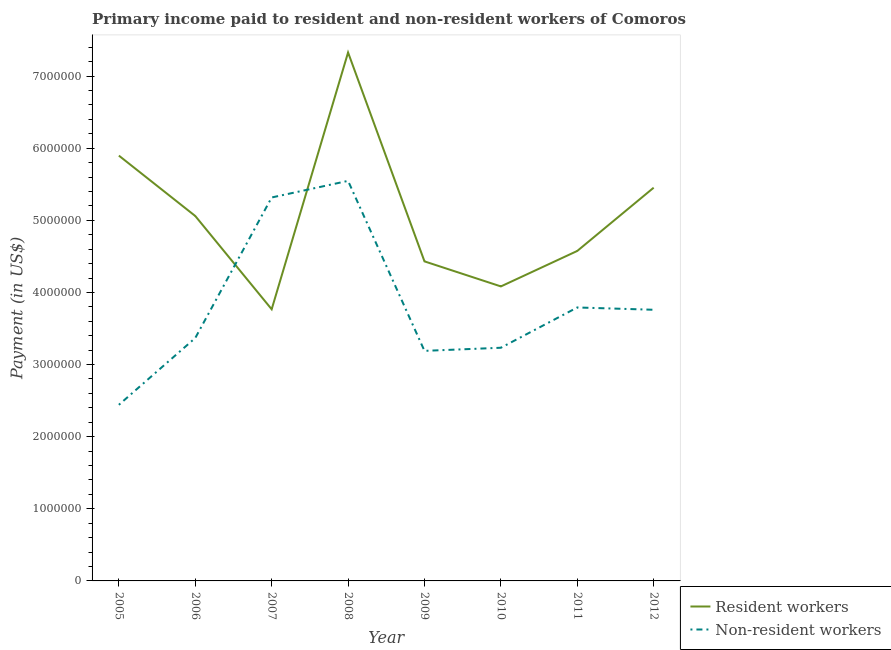How many different coloured lines are there?
Your response must be concise. 2. What is the payment made to non-resident workers in 2006?
Your answer should be compact. 3.37e+06. Across all years, what is the maximum payment made to resident workers?
Offer a terse response. 7.33e+06. Across all years, what is the minimum payment made to resident workers?
Your response must be concise. 3.77e+06. In which year was the payment made to non-resident workers maximum?
Provide a succinct answer. 2008. What is the total payment made to non-resident workers in the graph?
Offer a very short reply. 3.06e+07. What is the difference between the payment made to resident workers in 2007 and that in 2009?
Offer a very short reply. -6.64e+05. What is the difference between the payment made to resident workers in 2012 and the payment made to non-resident workers in 2011?
Your answer should be compact. 1.66e+06. What is the average payment made to non-resident workers per year?
Provide a succinct answer. 3.83e+06. In the year 2012, what is the difference between the payment made to resident workers and payment made to non-resident workers?
Your answer should be compact. 1.69e+06. In how many years, is the payment made to non-resident workers greater than 4400000 US$?
Offer a very short reply. 2. What is the ratio of the payment made to resident workers in 2008 to that in 2011?
Your answer should be very brief. 1.6. Is the payment made to non-resident workers in 2005 less than that in 2006?
Your answer should be very brief. Yes. Is the difference between the payment made to non-resident workers in 2005 and 2007 greater than the difference between the payment made to resident workers in 2005 and 2007?
Offer a terse response. No. What is the difference between the highest and the second highest payment made to non-resident workers?
Your response must be concise. 2.30e+05. What is the difference between the highest and the lowest payment made to non-resident workers?
Offer a terse response. 3.11e+06. Is the sum of the payment made to non-resident workers in 2005 and 2007 greater than the maximum payment made to resident workers across all years?
Give a very brief answer. Yes. How many lines are there?
Provide a succinct answer. 2. What is the difference between two consecutive major ticks on the Y-axis?
Keep it short and to the point. 1.00e+06. Does the graph contain any zero values?
Offer a very short reply. No. How are the legend labels stacked?
Provide a short and direct response. Vertical. What is the title of the graph?
Provide a succinct answer. Primary income paid to resident and non-resident workers of Comoros. What is the label or title of the X-axis?
Your response must be concise. Year. What is the label or title of the Y-axis?
Your response must be concise. Payment (in US$). What is the Payment (in US$) in Resident workers in 2005?
Provide a succinct answer. 5.90e+06. What is the Payment (in US$) in Non-resident workers in 2005?
Your answer should be compact. 2.44e+06. What is the Payment (in US$) in Resident workers in 2006?
Ensure brevity in your answer.  5.06e+06. What is the Payment (in US$) of Non-resident workers in 2006?
Your answer should be compact. 3.37e+06. What is the Payment (in US$) in Resident workers in 2007?
Keep it short and to the point. 3.77e+06. What is the Payment (in US$) in Non-resident workers in 2007?
Offer a terse response. 5.32e+06. What is the Payment (in US$) of Resident workers in 2008?
Keep it short and to the point. 7.33e+06. What is the Payment (in US$) of Non-resident workers in 2008?
Your answer should be compact. 5.55e+06. What is the Payment (in US$) of Resident workers in 2009?
Your response must be concise. 4.43e+06. What is the Payment (in US$) in Non-resident workers in 2009?
Provide a short and direct response. 3.19e+06. What is the Payment (in US$) of Resident workers in 2010?
Provide a succinct answer. 4.08e+06. What is the Payment (in US$) in Non-resident workers in 2010?
Offer a very short reply. 3.23e+06. What is the Payment (in US$) of Resident workers in 2011?
Offer a terse response. 4.58e+06. What is the Payment (in US$) of Non-resident workers in 2011?
Keep it short and to the point. 3.79e+06. What is the Payment (in US$) in Resident workers in 2012?
Offer a very short reply. 5.45e+06. What is the Payment (in US$) in Non-resident workers in 2012?
Your answer should be very brief. 3.76e+06. Across all years, what is the maximum Payment (in US$) of Resident workers?
Your answer should be very brief. 7.33e+06. Across all years, what is the maximum Payment (in US$) of Non-resident workers?
Offer a terse response. 5.55e+06. Across all years, what is the minimum Payment (in US$) of Resident workers?
Keep it short and to the point. 3.77e+06. Across all years, what is the minimum Payment (in US$) in Non-resident workers?
Provide a succinct answer. 2.44e+06. What is the total Payment (in US$) in Resident workers in the graph?
Your answer should be compact. 4.06e+07. What is the total Payment (in US$) of Non-resident workers in the graph?
Your answer should be compact. 3.06e+07. What is the difference between the Payment (in US$) of Resident workers in 2005 and that in 2006?
Your answer should be very brief. 8.37e+05. What is the difference between the Payment (in US$) in Non-resident workers in 2005 and that in 2006?
Ensure brevity in your answer.  -9.27e+05. What is the difference between the Payment (in US$) of Resident workers in 2005 and that in 2007?
Your response must be concise. 2.13e+06. What is the difference between the Payment (in US$) of Non-resident workers in 2005 and that in 2007?
Make the answer very short. -2.87e+06. What is the difference between the Payment (in US$) in Resident workers in 2005 and that in 2008?
Provide a succinct answer. -1.43e+06. What is the difference between the Payment (in US$) of Non-resident workers in 2005 and that in 2008?
Keep it short and to the point. -3.11e+06. What is the difference between the Payment (in US$) of Resident workers in 2005 and that in 2009?
Ensure brevity in your answer.  1.47e+06. What is the difference between the Payment (in US$) in Non-resident workers in 2005 and that in 2009?
Your response must be concise. -7.48e+05. What is the difference between the Payment (in US$) in Resident workers in 2005 and that in 2010?
Give a very brief answer. 1.81e+06. What is the difference between the Payment (in US$) in Non-resident workers in 2005 and that in 2010?
Ensure brevity in your answer.  -7.91e+05. What is the difference between the Payment (in US$) of Resident workers in 2005 and that in 2011?
Keep it short and to the point. 1.32e+06. What is the difference between the Payment (in US$) in Non-resident workers in 2005 and that in 2011?
Make the answer very short. -1.35e+06. What is the difference between the Payment (in US$) of Resident workers in 2005 and that in 2012?
Ensure brevity in your answer.  4.45e+05. What is the difference between the Payment (in US$) in Non-resident workers in 2005 and that in 2012?
Your response must be concise. -1.32e+06. What is the difference between the Payment (in US$) of Resident workers in 2006 and that in 2007?
Make the answer very short. 1.29e+06. What is the difference between the Payment (in US$) in Non-resident workers in 2006 and that in 2007?
Offer a very short reply. -1.95e+06. What is the difference between the Payment (in US$) in Resident workers in 2006 and that in 2008?
Ensure brevity in your answer.  -2.27e+06. What is the difference between the Payment (in US$) of Non-resident workers in 2006 and that in 2008?
Provide a succinct answer. -2.18e+06. What is the difference between the Payment (in US$) in Resident workers in 2006 and that in 2009?
Provide a succinct answer. 6.29e+05. What is the difference between the Payment (in US$) in Non-resident workers in 2006 and that in 2009?
Your response must be concise. 1.78e+05. What is the difference between the Payment (in US$) of Resident workers in 2006 and that in 2010?
Provide a short and direct response. 9.76e+05. What is the difference between the Payment (in US$) in Non-resident workers in 2006 and that in 2010?
Make the answer very short. 1.35e+05. What is the difference between the Payment (in US$) of Resident workers in 2006 and that in 2011?
Offer a terse response. 4.84e+05. What is the difference between the Payment (in US$) of Non-resident workers in 2006 and that in 2011?
Offer a terse response. -4.23e+05. What is the difference between the Payment (in US$) in Resident workers in 2006 and that in 2012?
Keep it short and to the point. -3.93e+05. What is the difference between the Payment (in US$) in Non-resident workers in 2006 and that in 2012?
Your answer should be very brief. -3.91e+05. What is the difference between the Payment (in US$) of Resident workers in 2007 and that in 2008?
Your answer should be compact. -3.56e+06. What is the difference between the Payment (in US$) of Non-resident workers in 2007 and that in 2008?
Your answer should be compact. -2.30e+05. What is the difference between the Payment (in US$) in Resident workers in 2007 and that in 2009?
Your response must be concise. -6.64e+05. What is the difference between the Payment (in US$) of Non-resident workers in 2007 and that in 2009?
Offer a very short reply. 2.13e+06. What is the difference between the Payment (in US$) in Resident workers in 2007 and that in 2010?
Offer a terse response. -3.17e+05. What is the difference between the Payment (in US$) in Non-resident workers in 2007 and that in 2010?
Your answer should be compact. 2.08e+06. What is the difference between the Payment (in US$) of Resident workers in 2007 and that in 2011?
Your answer should be compact. -8.09e+05. What is the difference between the Payment (in US$) in Non-resident workers in 2007 and that in 2011?
Provide a short and direct response. 1.52e+06. What is the difference between the Payment (in US$) in Resident workers in 2007 and that in 2012?
Keep it short and to the point. -1.69e+06. What is the difference between the Payment (in US$) in Non-resident workers in 2007 and that in 2012?
Keep it short and to the point. 1.56e+06. What is the difference between the Payment (in US$) in Resident workers in 2008 and that in 2009?
Your response must be concise. 2.90e+06. What is the difference between the Payment (in US$) in Non-resident workers in 2008 and that in 2009?
Your answer should be compact. 2.36e+06. What is the difference between the Payment (in US$) of Resident workers in 2008 and that in 2010?
Ensure brevity in your answer.  3.24e+06. What is the difference between the Payment (in US$) of Non-resident workers in 2008 and that in 2010?
Offer a terse response. 2.31e+06. What is the difference between the Payment (in US$) in Resident workers in 2008 and that in 2011?
Give a very brief answer. 2.75e+06. What is the difference between the Payment (in US$) of Non-resident workers in 2008 and that in 2011?
Your response must be concise. 1.76e+06. What is the difference between the Payment (in US$) of Resident workers in 2008 and that in 2012?
Give a very brief answer. 1.87e+06. What is the difference between the Payment (in US$) of Non-resident workers in 2008 and that in 2012?
Give a very brief answer. 1.79e+06. What is the difference between the Payment (in US$) of Resident workers in 2009 and that in 2010?
Offer a terse response. 3.47e+05. What is the difference between the Payment (in US$) in Non-resident workers in 2009 and that in 2010?
Provide a succinct answer. -4.30e+04. What is the difference between the Payment (in US$) of Resident workers in 2009 and that in 2011?
Make the answer very short. -1.45e+05. What is the difference between the Payment (in US$) of Non-resident workers in 2009 and that in 2011?
Provide a succinct answer. -6.02e+05. What is the difference between the Payment (in US$) in Resident workers in 2009 and that in 2012?
Ensure brevity in your answer.  -1.02e+06. What is the difference between the Payment (in US$) in Non-resident workers in 2009 and that in 2012?
Give a very brief answer. -5.70e+05. What is the difference between the Payment (in US$) of Resident workers in 2010 and that in 2011?
Keep it short and to the point. -4.92e+05. What is the difference between the Payment (in US$) of Non-resident workers in 2010 and that in 2011?
Offer a terse response. -5.59e+05. What is the difference between the Payment (in US$) in Resident workers in 2010 and that in 2012?
Keep it short and to the point. -1.37e+06. What is the difference between the Payment (in US$) in Non-resident workers in 2010 and that in 2012?
Provide a succinct answer. -5.27e+05. What is the difference between the Payment (in US$) of Resident workers in 2011 and that in 2012?
Keep it short and to the point. -8.77e+05. What is the difference between the Payment (in US$) of Non-resident workers in 2011 and that in 2012?
Your response must be concise. 3.19e+04. What is the difference between the Payment (in US$) of Resident workers in 2005 and the Payment (in US$) of Non-resident workers in 2006?
Ensure brevity in your answer.  2.53e+06. What is the difference between the Payment (in US$) in Resident workers in 2005 and the Payment (in US$) in Non-resident workers in 2007?
Ensure brevity in your answer.  5.81e+05. What is the difference between the Payment (in US$) of Resident workers in 2005 and the Payment (in US$) of Non-resident workers in 2008?
Your answer should be very brief. 3.50e+05. What is the difference between the Payment (in US$) in Resident workers in 2005 and the Payment (in US$) in Non-resident workers in 2009?
Make the answer very short. 2.71e+06. What is the difference between the Payment (in US$) in Resident workers in 2005 and the Payment (in US$) in Non-resident workers in 2010?
Give a very brief answer. 2.66e+06. What is the difference between the Payment (in US$) in Resident workers in 2005 and the Payment (in US$) in Non-resident workers in 2011?
Make the answer very short. 2.11e+06. What is the difference between the Payment (in US$) in Resident workers in 2005 and the Payment (in US$) in Non-resident workers in 2012?
Provide a succinct answer. 2.14e+06. What is the difference between the Payment (in US$) in Resident workers in 2006 and the Payment (in US$) in Non-resident workers in 2007?
Offer a terse response. -2.57e+05. What is the difference between the Payment (in US$) in Resident workers in 2006 and the Payment (in US$) in Non-resident workers in 2008?
Offer a very short reply. -4.87e+05. What is the difference between the Payment (in US$) in Resident workers in 2006 and the Payment (in US$) in Non-resident workers in 2009?
Provide a short and direct response. 1.87e+06. What is the difference between the Payment (in US$) of Resident workers in 2006 and the Payment (in US$) of Non-resident workers in 2010?
Provide a short and direct response. 1.83e+06. What is the difference between the Payment (in US$) of Resident workers in 2006 and the Payment (in US$) of Non-resident workers in 2011?
Your response must be concise. 1.27e+06. What is the difference between the Payment (in US$) of Resident workers in 2006 and the Payment (in US$) of Non-resident workers in 2012?
Your answer should be compact. 1.30e+06. What is the difference between the Payment (in US$) in Resident workers in 2007 and the Payment (in US$) in Non-resident workers in 2008?
Offer a terse response. -1.78e+06. What is the difference between the Payment (in US$) in Resident workers in 2007 and the Payment (in US$) in Non-resident workers in 2009?
Provide a succinct answer. 5.77e+05. What is the difference between the Payment (in US$) of Resident workers in 2007 and the Payment (in US$) of Non-resident workers in 2010?
Make the answer very short. 5.34e+05. What is the difference between the Payment (in US$) of Resident workers in 2007 and the Payment (in US$) of Non-resident workers in 2011?
Your response must be concise. -2.51e+04. What is the difference between the Payment (in US$) of Resident workers in 2007 and the Payment (in US$) of Non-resident workers in 2012?
Make the answer very short. 6854.8. What is the difference between the Payment (in US$) of Resident workers in 2008 and the Payment (in US$) of Non-resident workers in 2009?
Offer a very short reply. 4.14e+06. What is the difference between the Payment (in US$) of Resident workers in 2008 and the Payment (in US$) of Non-resident workers in 2010?
Provide a short and direct response. 4.09e+06. What is the difference between the Payment (in US$) of Resident workers in 2008 and the Payment (in US$) of Non-resident workers in 2011?
Provide a short and direct response. 3.54e+06. What is the difference between the Payment (in US$) of Resident workers in 2008 and the Payment (in US$) of Non-resident workers in 2012?
Offer a terse response. 3.57e+06. What is the difference between the Payment (in US$) in Resident workers in 2009 and the Payment (in US$) in Non-resident workers in 2010?
Your response must be concise. 1.20e+06. What is the difference between the Payment (in US$) in Resident workers in 2009 and the Payment (in US$) in Non-resident workers in 2011?
Offer a very short reply. 6.39e+05. What is the difference between the Payment (in US$) in Resident workers in 2009 and the Payment (in US$) in Non-resident workers in 2012?
Ensure brevity in your answer.  6.71e+05. What is the difference between the Payment (in US$) in Resident workers in 2010 and the Payment (in US$) in Non-resident workers in 2011?
Give a very brief answer. 2.92e+05. What is the difference between the Payment (in US$) of Resident workers in 2010 and the Payment (in US$) of Non-resident workers in 2012?
Your answer should be very brief. 3.24e+05. What is the difference between the Payment (in US$) of Resident workers in 2011 and the Payment (in US$) of Non-resident workers in 2012?
Keep it short and to the point. 8.16e+05. What is the average Payment (in US$) in Resident workers per year?
Keep it short and to the point. 5.07e+06. What is the average Payment (in US$) of Non-resident workers per year?
Your answer should be compact. 3.83e+06. In the year 2005, what is the difference between the Payment (in US$) in Resident workers and Payment (in US$) in Non-resident workers?
Your answer should be compact. 3.46e+06. In the year 2006, what is the difference between the Payment (in US$) in Resident workers and Payment (in US$) in Non-resident workers?
Your answer should be very brief. 1.69e+06. In the year 2007, what is the difference between the Payment (in US$) of Resident workers and Payment (in US$) of Non-resident workers?
Offer a very short reply. -1.55e+06. In the year 2008, what is the difference between the Payment (in US$) in Resident workers and Payment (in US$) in Non-resident workers?
Offer a terse response. 1.78e+06. In the year 2009, what is the difference between the Payment (in US$) of Resident workers and Payment (in US$) of Non-resident workers?
Offer a very short reply. 1.24e+06. In the year 2010, what is the difference between the Payment (in US$) of Resident workers and Payment (in US$) of Non-resident workers?
Give a very brief answer. 8.51e+05. In the year 2011, what is the difference between the Payment (in US$) in Resident workers and Payment (in US$) in Non-resident workers?
Ensure brevity in your answer.  7.84e+05. In the year 2012, what is the difference between the Payment (in US$) of Resident workers and Payment (in US$) of Non-resident workers?
Make the answer very short. 1.69e+06. What is the ratio of the Payment (in US$) of Resident workers in 2005 to that in 2006?
Your answer should be very brief. 1.17. What is the ratio of the Payment (in US$) in Non-resident workers in 2005 to that in 2006?
Keep it short and to the point. 0.72. What is the ratio of the Payment (in US$) of Resident workers in 2005 to that in 2007?
Make the answer very short. 1.57. What is the ratio of the Payment (in US$) in Non-resident workers in 2005 to that in 2007?
Offer a terse response. 0.46. What is the ratio of the Payment (in US$) of Resident workers in 2005 to that in 2008?
Offer a very short reply. 0.8. What is the ratio of the Payment (in US$) in Non-resident workers in 2005 to that in 2008?
Make the answer very short. 0.44. What is the ratio of the Payment (in US$) of Resident workers in 2005 to that in 2009?
Offer a terse response. 1.33. What is the ratio of the Payment (in US$) in Non-resident workers in 2005 to that in 2009?
Your answer should be compact. 0.77. What is the ratio of the Payment (in US$) in Resident workers in 2005 to that in 2010?
Ensure brevity in your answer.  1.44. What is the ratio of the Payment (in US$) of Non-resident workers in 2005 to that in 2010?
Offer a very short reply. 0.76. What is the ratio of the Payment (in US$) of Resident workers in 2005 to that in 2011?
Give a very brief answer. 1.29. What is the ratio of the Payment (in US$) of Non-resident workers in 2005 to that in 2011?
Offer a terse response. 0.64. What is the ratio of the Payment (in US$) in Resident workers in 2005 to that in 2012?
Keep it short and to the point. 1.08. What is the ratio of the Payment (in US$) in Non-resident workers in 2005 to that in 2012?
Your response must be concise. 0.65. What is the ratio of the Payment (in US$) in Resident workers in 2006 to that in 2007?
Keep it short and to the point. 1.34. What is the ratio of the Payment (in US$) in Non-resident workers in 2006 to that in 2007?
Keep it short and to the point. 0.63. What is the ratio of the Payment (in US$) in Resident workers in 2006 to that in 2008?
Your answer should be very brief. 0.69. What is the ratio of the Payment (in US$) in Non-resident workers in 2006 to that in 2008?
Your answer should be very brief. 0.61. What is the ratio of the Payment (in US$) in Resident workers in 2006 to that in 2009?
Make the answer very short. 1.14. What is the ratio of the Payment (in US$) of Non-resident workers in 2006 to that in 2009?
Your answer should be very brief. 1.06. What is the ratio of the Payment (in US$) in Resident workers in 2006 to that in 2010?
Ensure brevity in your answer.  1.24. What is the ratio of the Payment (in US$) in Non-resident workers in 2006 to that in 2010?
Your answer should be compact. 1.04. What is the ratio of the Payment (in US$) of Resident workers in 2006 to that in 2011?
Offer a terse response. 1.11. What is the ratio of the Payment (in US$) in Non-resident workers in 2006 to that in 2011?
Your answer should be compact. 0.89. What is the ratio of the Payment (in US$) of Resident workers in 2006 to that in 2012?
Your response must be concise. 0.93. What is the ratio of the Payment (in US$) of Non-resident workers in 2006 to that in 2012?
Ensure brevity in your answer.  0.9. What is the ratio of the Payment (in US$) of Resident workers in 2007 to that in 2008?
Keep it short and to the point. 0.51. What is the ratio of the Payment (in US$) of Non-resident workers in 2007 to that in 2008?
Your answer should be very brief. 0.96. What is the ratio of the Payment (in US$) in Resident workers in 2007 to that in 2009?
Your response must be concise. 0.85. What is the ratio of the Payment (in US$) in Non-resident workers in 2007 to that in 2009?
Give a very brief answer. 1.67. What is the ratio of the Payment (in US$) in Resident workers in 2007 to that in 2010?
Offer a terse response. 0.92. What is the ratio of the Payment (in US$) in Non-resident workers in 2007 to that in 2010?
Your response must be concise. 1.64. What is the ratio of the Payment (in US$) in Resident workers in 2007 to that in 2011?
Ensure brevity in your answer.  0.82. What is the ratio of the Payment (in US$) in Non-resident workers in 2007 to that in 2011?
Your answer should be compact. 1.4. What is the ratio of the Payment (in US$) of Resident workers in 2007 to that in 2012?
Your answer should be very brief. 0.69. What is the ratio of the Payment (in US$) of Non-resident workers in 2007 to that in 2012?
Your answer should be compact. 1.41. What is the ratio of the Payment (in US$) in Resident workers in 2008 to that in 2009?
Offer a very short reply. 1.65. What is the ratio of the Payment (in US$) in Non-resident workers in 2008 to that in 2009?
Make the answer very short. 1.74. What is the ratio of the Payment (in US$) of Resident workers in 2008 to that in 2010?
Your answer should be very brief. 1.79. What is the ratio of the Payment (in US$) in Non-resident workers in 2008 to that in 2010?
Keep it short and to the point. 1.72. What is the ratio of the Payment (in US$) in Resident workers in 2008 to that in 2011?
Offer a terse response. 1.6. What is the ratio of the Payment (in US$) of Non-resident workers in 2008 to that in 2011?
Your answer should be very brief. 1.46. What is the ratio of the Payment (in US$) in Resident workers in 2008 to that in 2012?
Keep it short and to the point. 1.34. What is the ratio of the Payment (in US$) in Non-resident workers in 2008 to that in 2012?
Your answer should be compact. 1.48. What is the ratio of the Payment (in US$) in Resident workers in 2009 to that in 2010?
Your answer should be compact. 1.08. What is the ratio of the Payment (in US$) of Non-resident workers in 2009 to that in 2010?
Ensure brevity in your answer.  0.99. What is the ratio of the Payment (in US$) of Resident workers in 2009 to that in 2011?
Give a very brief answer. 0.97. What is the ratio of the Payment (in US$) in Non-resident workers in 2009 to that in 2011?
Provide a short and direct response. 0.84. What is the ratio of the Payment (in US$) of Resident workers in 2009 to that in 2012?
Your answer should be very brief. 0.81. What is the ratio of the Payment (in US$) in Non-resident workers in 2009 to that in 2012?
Your answer should be very brief. 0.85. What is the ratio of the Payment (in US$) of Resident workers in 2010 to that in 2011?
Your answer should be compact. 0.89. What is the ratio of the Payment (in US$) of Non-resident workers in 2010 to that in 2011?
Your answer should be compact. 0.85. What is the ratio of the Payment (in US$) of Resident workers in 2010 to that in 2012?
Ensure brevity in your answer.  0.75. What is the ratio of the Payment (in US$) in Non-resident workers in 2010 to that in 2012?
Offer a very short reply. 0.86. What is the ratio of the Payment (in US$) in Resident workers in 2011 to that in 2012?
Ensure brevity in your answer.  0.84. What is the ratio of the Payment (in US$) in Non-resident workers in 2011 to that in 2012?
Keep it short and to the point. 1.01. What is the difference between the highest and the second highest Payment (in US$) of Resident workers?
Make the answer very short. 1.43e+06. What is the difference between the highest and the second highest Payment (in US$) of Non-resident workers?
Give a very brief answer. 2.30e+05. What is the difference between the highest and the lowest Payment (in US$) of Resident workers?
Your answer should be very brief. 3.56e+06. What is the difference between the highest and the lowest Payment (in US$) in Non-resident workers?
Offer a terse response. 3.11e+06. 